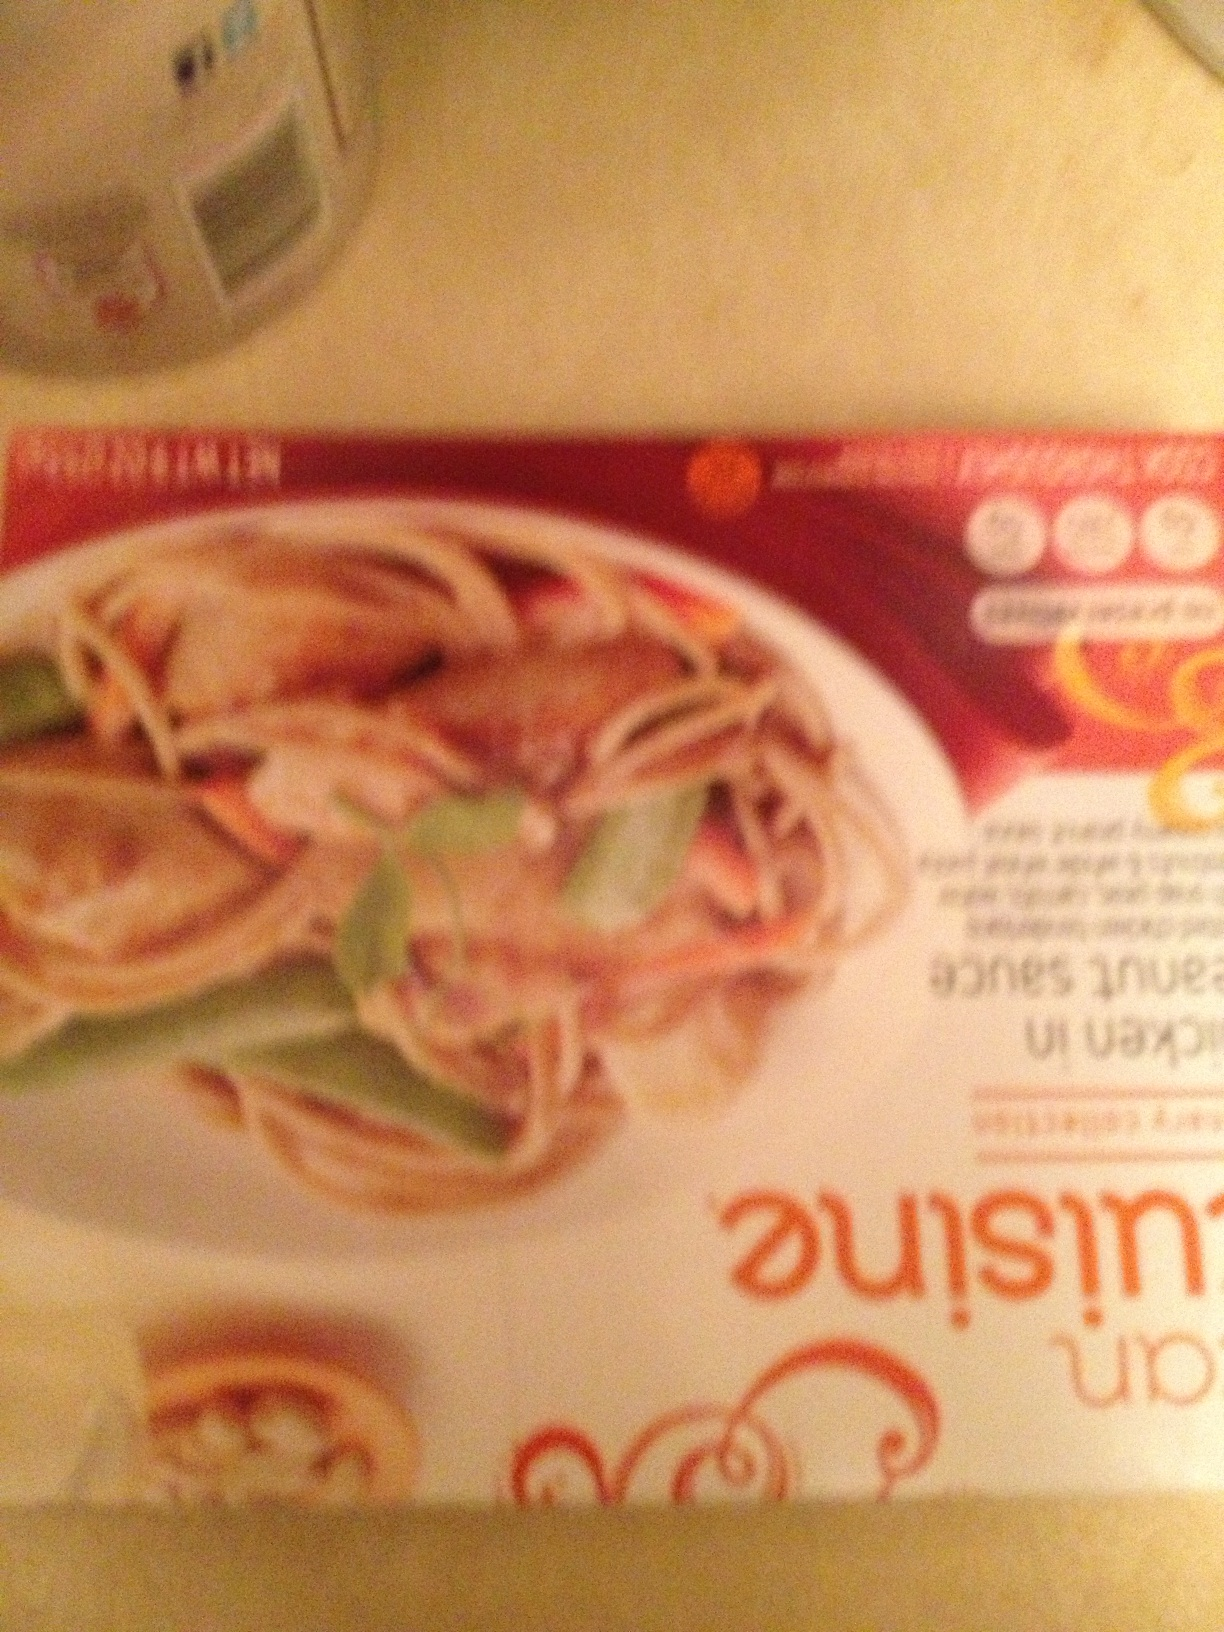What is this meal? The image depicts a package of what appears to be an Asian-style noodle dish, possibly Thai or Vietnamese, featuring shrimps and vegetables, based on the visible imagery and text layout common in packaged meals of that cuisine. The exact name and ingredients cannot be determined due to the blurriness of the image. 